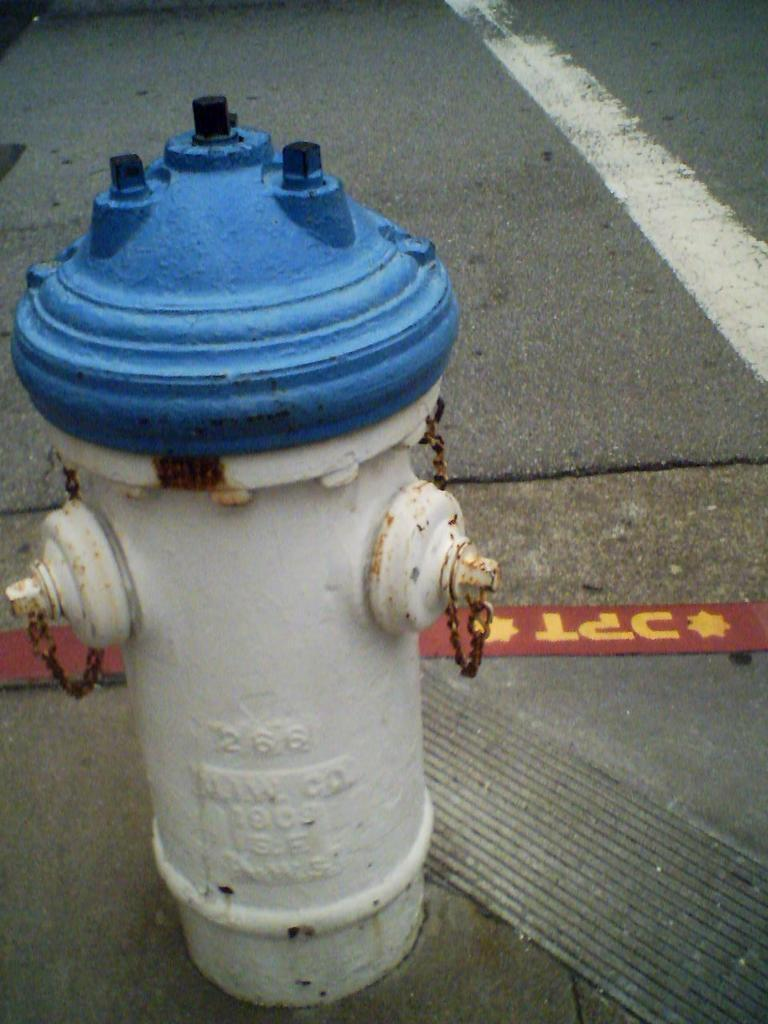What is the main object in the image? There is a water hydrant in the image. Where is the water hydrant located in relation to the image? The water hydrant is in the front of the image. What can be seen in the background of the image? There is a road visible in the background of the image. What type of vase is placed on the board in the office in the image? There is no vase, board, or office present in the image; it only features a water hydrant in the front and a road in the background. 